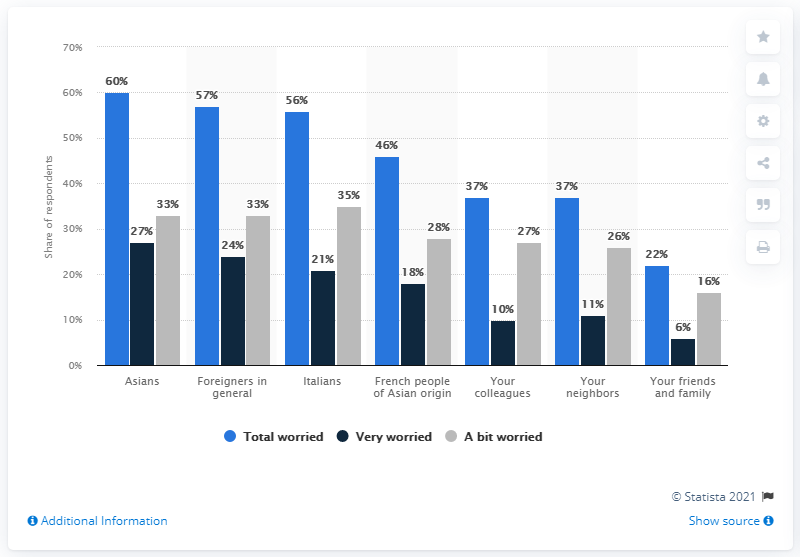Give some essential details in this illustration. Some people, particularly Asians, are known to worry very highly about handshaking. The highest worried and lowest worried people differ by 38.. 